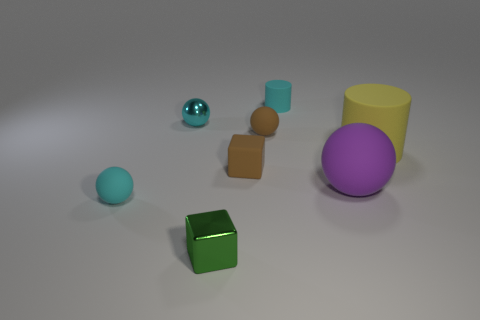Is there a small purple object of the same shape as the big yellow thing?
Provide a succinct answer. No. There is a cyan rubber thing left of the small cyan cylinder; does it have the same shape as the big yellow object?
Your response must be concise. No. What number of tiny metal objects are both left of the small metal cube and in front of the brown matte cube?
Offer a terse response. 0. The small cyan rubber object in front of the tiny matte cylinder has what shape?
Keep it short and to the point. Sphere. How many other big things are the same material as the yellow object?
Provide a succinct answer. 1. There is a big yellow object; is it the same shape as the small matte thing that is in front of the brown rubber block?
Your answer should be very brief. No. Are there any brown rubber balls behind the small matte sphere that is on the right side of the cyan rubber object that is to the left of the cyan metallic object?
Your answer should be very brief. No. There is a thing on the right side of the big purple thing; what is its size?
Your answer should be compact. Large. There is another block that is the same size as the green cube; what is it made of?
Make the answer very short. Rubber. Is the large yellow object the same shape as the tiny cyan shiny object?
Offer a terse response. No. 